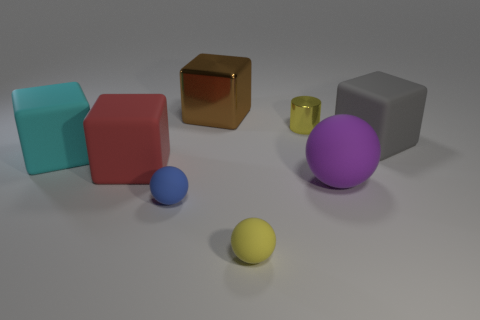Subtract 1 blocks. How many blocks are left? 3 Subtract all brown cubes. How many cubes are left? 3 Subtract all red rubber blocks. How many blocks are left? 3 Subtract all yellow cubes. Subtract all blue balls. How many cubes are left? 4 Add 2 cyan matte objects. How many objects exist? 10 Subtract all cylinders. How many objects are left? 7 Add 8 gray matte things. How many gray matte things exist? 9 Subtract 0 green cylinders. How many objects are left? 8 Subtract all tiny metal objects. Subtract all big red rubber objects. How many objects are left? 6 Add 5 tiny metal cylinders. How many tiny metal cylinders are left? 6 